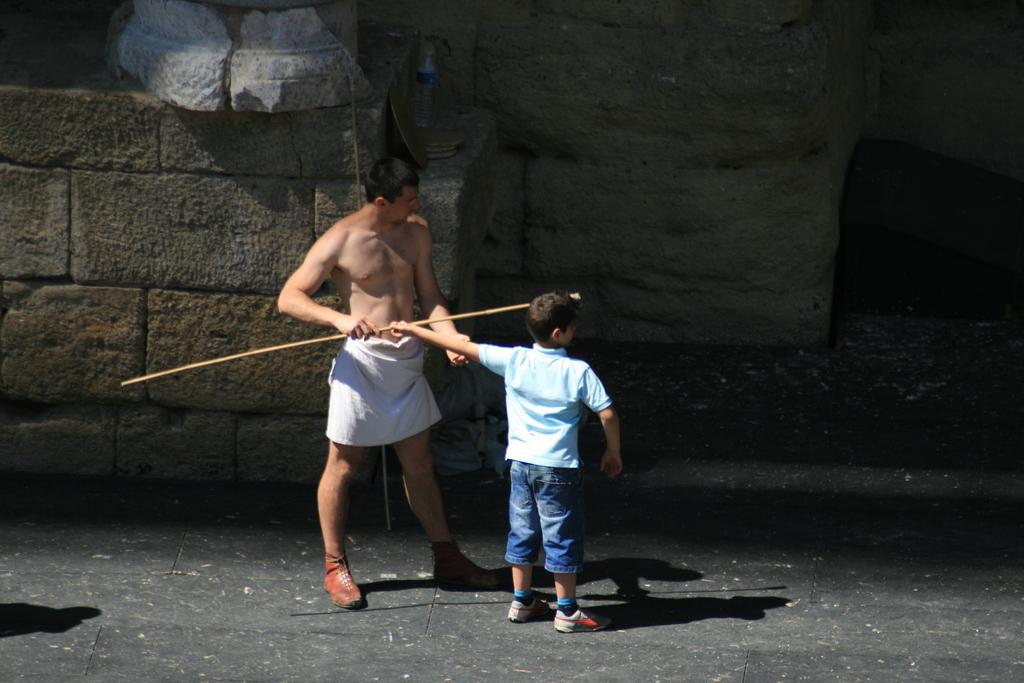In one or two sentences, can you explain what this image depicts? In this image in the center there are persons standing. In the background there is a wall and there is a man standing and holding a stick in his hand. 